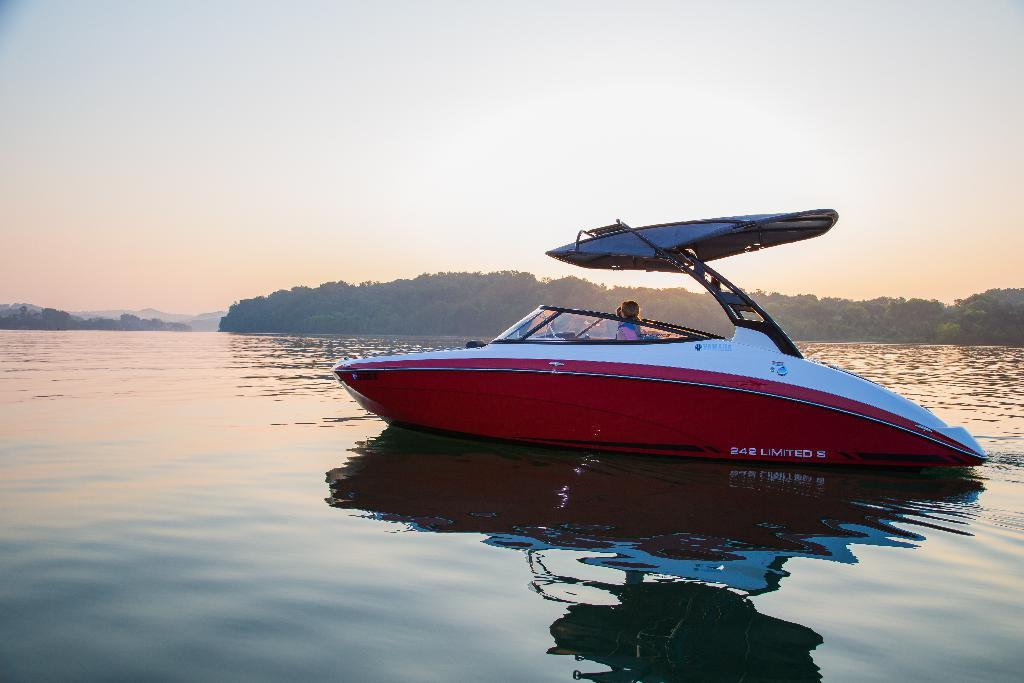What is the person in the image doing? The person is in a boat in the image. Where is the boat located? The boat is in a large water body. What can be seen in the background of the image? There is a group of trees and hills visible in the image. How would you describe the weather in the image? The sky is cloudy in the image. What type of curtain is hanging from the boat in the image? There is no curtain hanging from the boat in the image. 